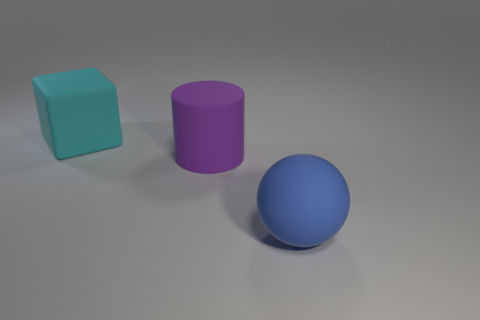Can you explain the arrangement of the objects? Certainly, the objects are arranged with some space between them on a flat surface. The cylindrical object is between the cube and the sphere, which introduces variety in shape and color comparative composition and allows for easy visual distinction between the items. Does the arrangement imply any specific interaction between the objects? The arrangement doesn’t imply direct interaction between the objects. They are positioned separately, and there are no signs of physical interaction or connection. It is a simple, static layout, possibly for display or educational purposes. 